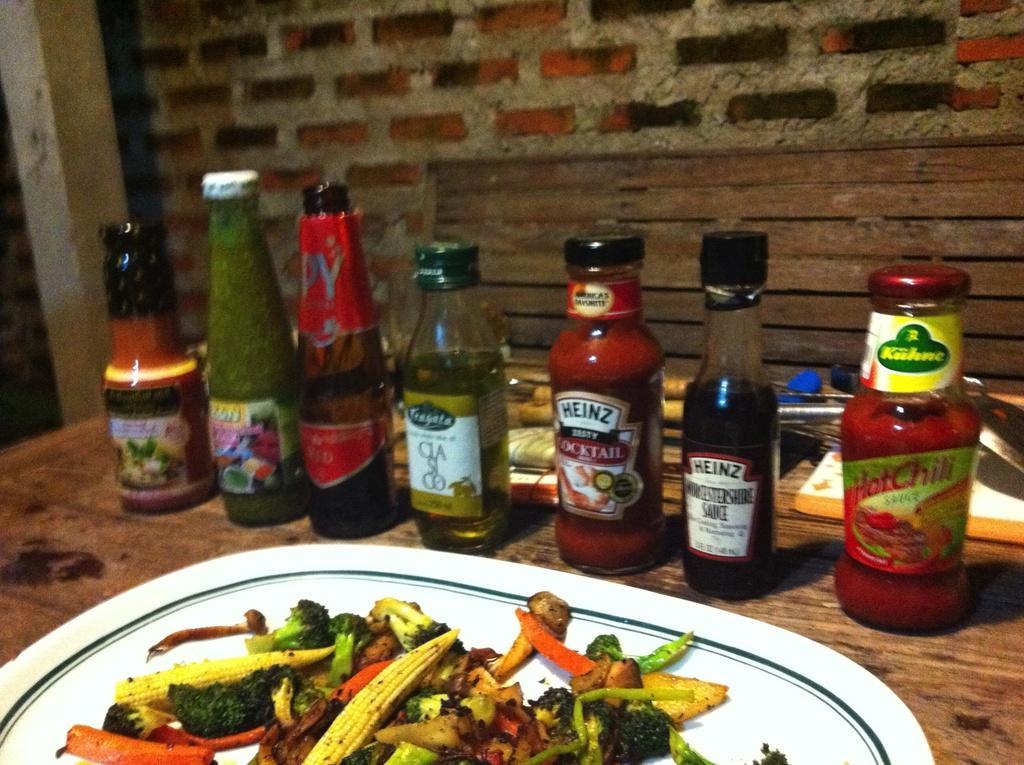How would you summarize this image in a sentence or two? This picture shows bottles and some food in the plate on the table 